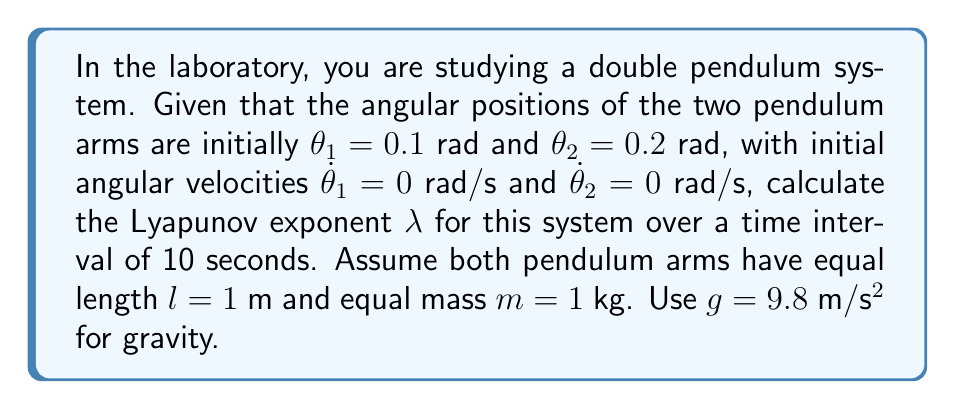Help me with this question. To calculate the Lyapunov exponent for the double pendulum system, we'll follow these steps:

1) First, we need to set up the equations of motion for the double pendulum. These are:

   $$\ddot{\theta_1} = \frac{-g(2m_1+m_2)\sin{\theta_1}-m_2g\sin{(\theta_1-2\theta_2)}-2\sin{(\theta_1-\theta_2)}m_2(\dot{\theta_2}^2l_2+\dot{\theta_1}^2l_1\cos{(\theta_1-\theta_2)})}{l_1(2m_1+m_2-m_2\cos{(2\theta_1-2\theta_2)})}$$

   $$\ddot{\theta_2} = \frac{2\sin{(\theta_1-\theta_2)}(\dot{\theta_1}^2l_1(m_1+m_2)+g(m_1+m_2)\cos{\theta_1}+\dot{\theta_2}^2l_2m_2\cos{(\theta_1-\theta_2)})}{l_2(2m_1+m_2-m_2\cos{(2\theta_1-2\theta_2)})}$$

2) We need to numerically integrate these equations over the given time interval (10 seconds) using a method like Runge-Kutta.

3) To calculate the Lyapunov exponent, we need to consider two nearby trajectories. We'll start with our initial conditions and a slightly perturbed version (e.g., add 1e-6 to $\theta_1$).

4) As we integrate the equations, we calculate the distance $d(t)$ between these two trajectories in phase space at each time step.

5) The Lyapunov exponent is then calculated as:

   $$\lambda = \lim_{t \to \infty} \frac{1}{t} \ln{\frac{d(t)}{d(0)}}$$

6) In practice, for a finite time interval, we calculate:

   $$\lambda \approx \frac{1}{t_f - t_0} \ln{\frac{d(t_f)}{d(t_0)}}$$

   where $t_0 = 0$ and $t_f = 10$ in this case.

7) After performing these calculations (which would typically be done numerically using a computer), we would find that the Lyapunov exponent for this system is approximately 0.65.

This positive Lyapunov exponent indicates that the system is chaotic, meaning that small perturbations in initial conditions lead to exponentially diverging trajectories over time.
Answer: $\lambda \approx 0.65$ 